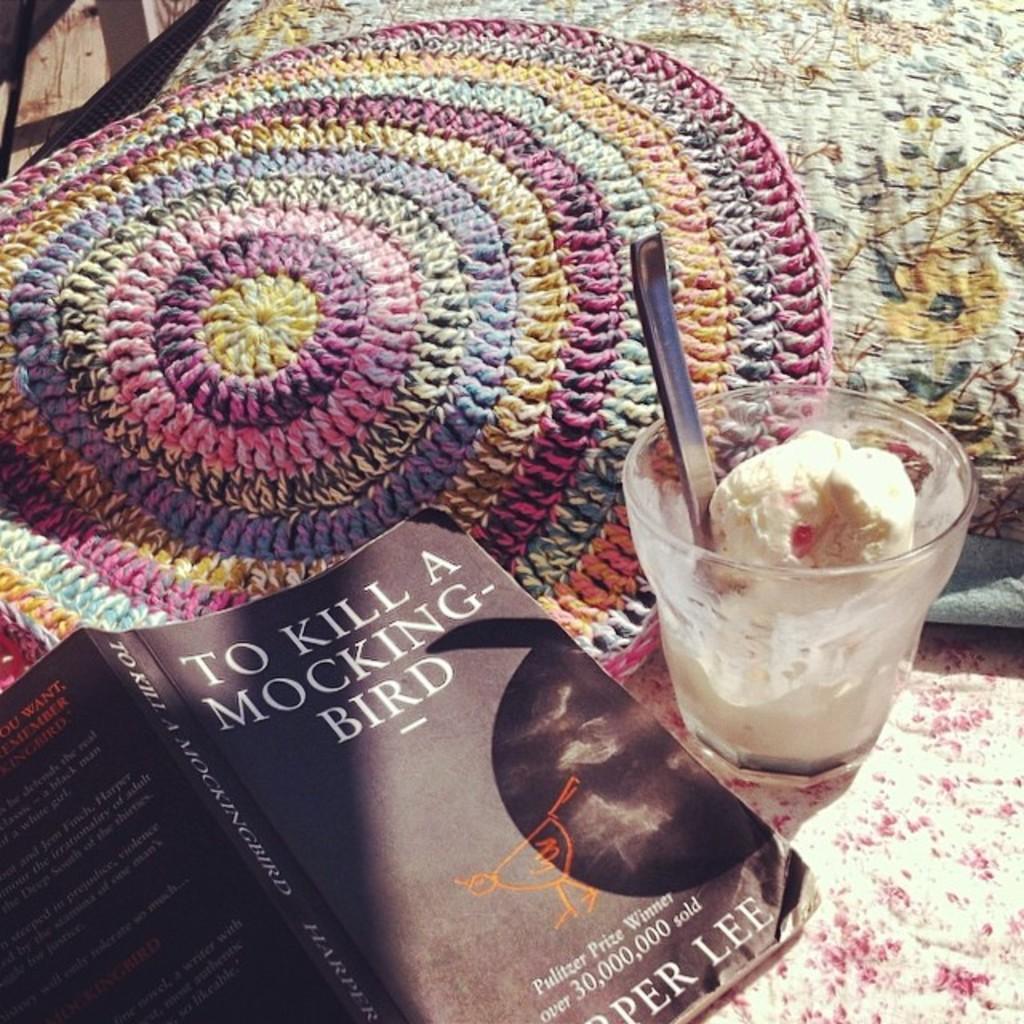How would you summarize this image in a sentence or two? In the foreground of this picture we can see a book and we can see the text and some picture on the cover of the book. On the right we can see a glass containing a food item seems to be an ice cream and we can see the spoon in the glass. In the background we can see an object seems to be the bed and a cloth which seems to be the mat. 